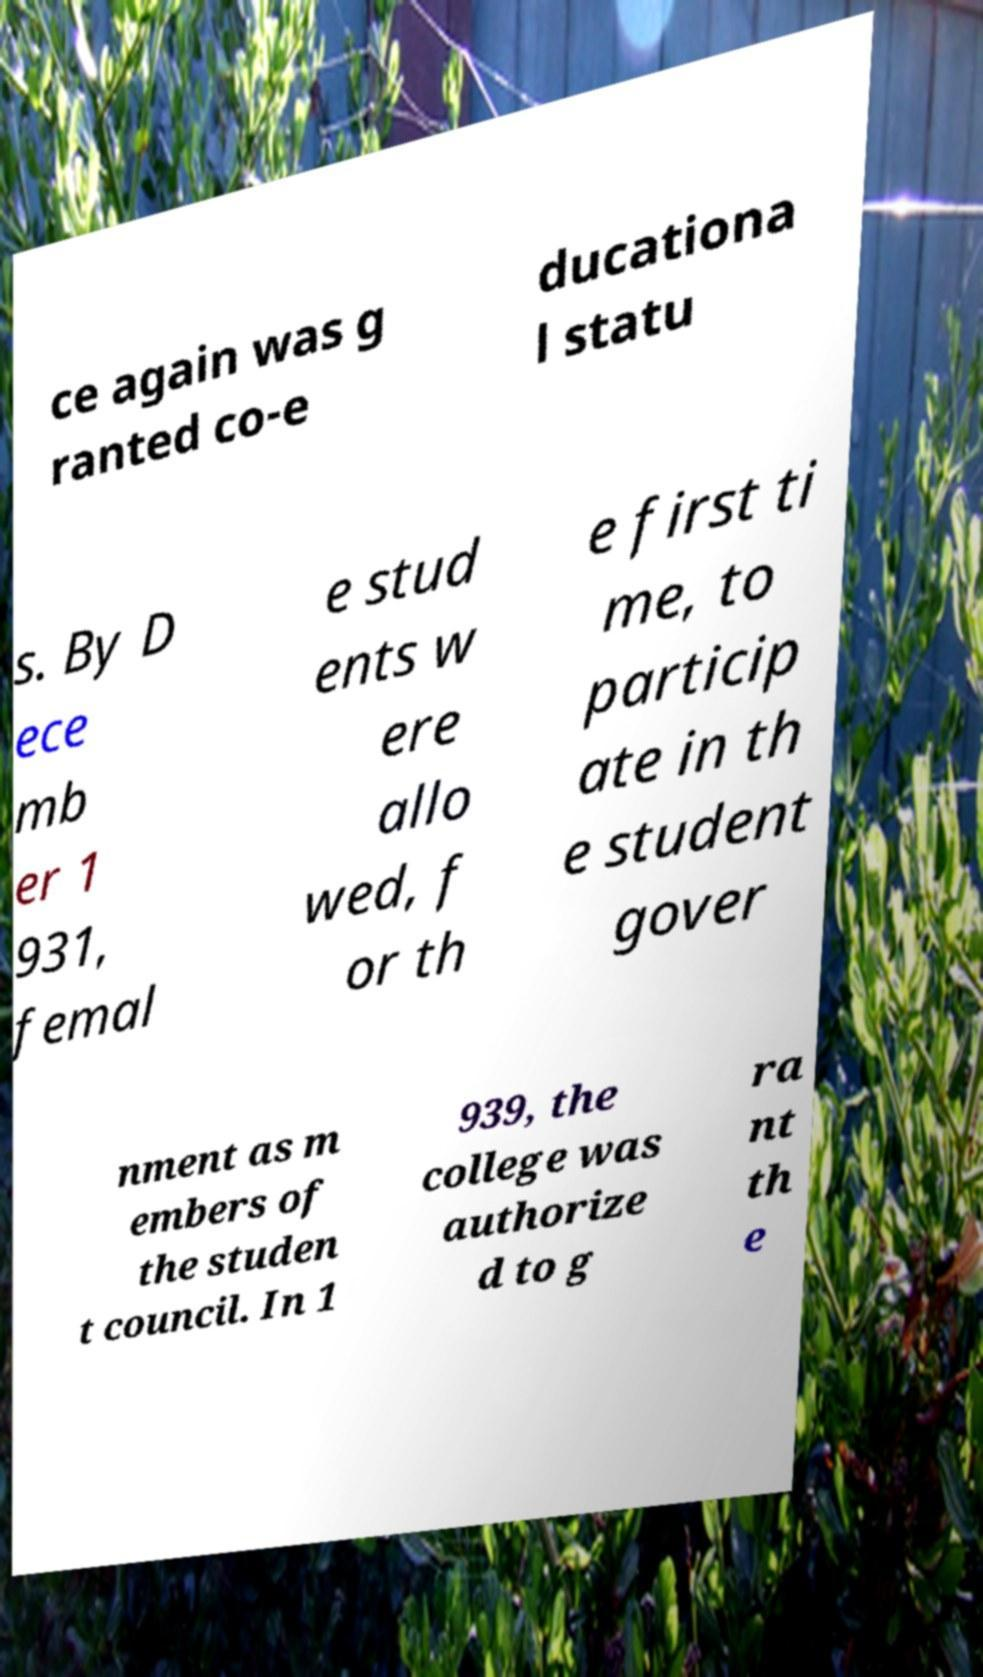Could you extract and type out the text from this image? ce again was g ranted co-e ducationa l statu s. By D ece mb er 1 931, femal e stud ents w ere allo wed, f or th e first ti me, to particip ate in th e student gover nment as m embers of the studen t council. In 1 939, the college was authorize d to g ra nt th e 